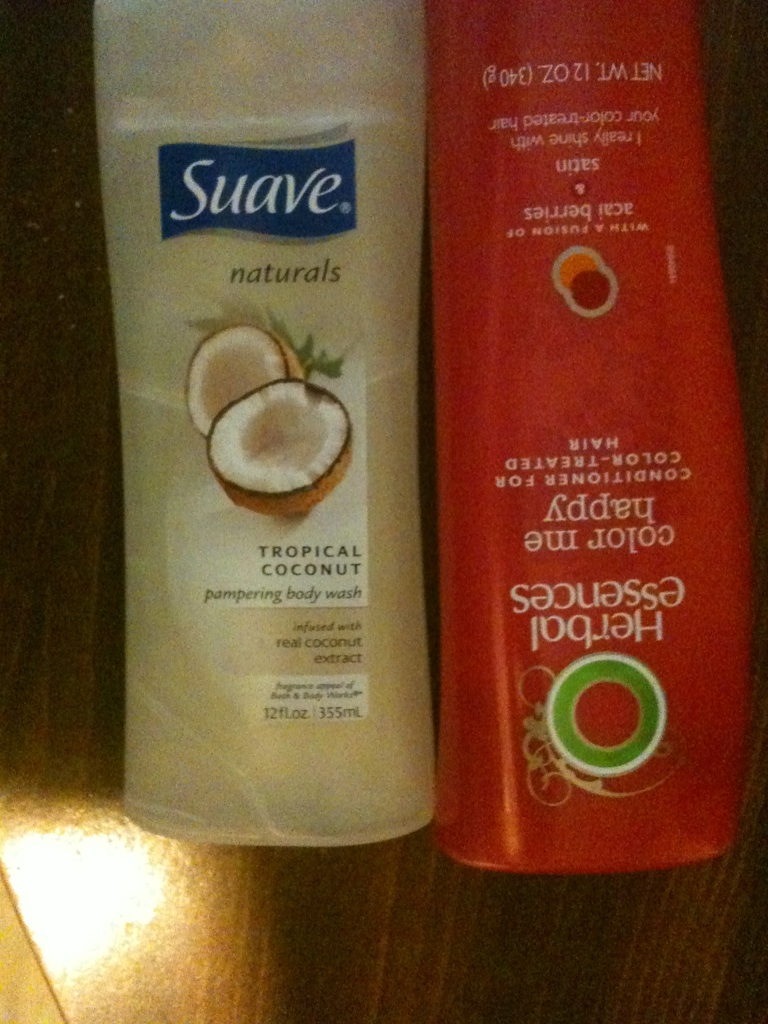Imagine a realistic scenario where someone might use these products. In a realistic scenario, imagine someone who just came home after a long, stressful day at work. They head to the shower and use the Suave Tropical Coconut Pampering Body Wash to cleanse and hydrate their skin, enjoying the relaxing coconut aroma. After washing, they apply the Herbal Essences Color Me Happy Conditioner to their color-treated hair, ensuring it remains vibrant and shiny. This routine helps them unwind and feel rejuvenated, ready to face the next day with confidence. 